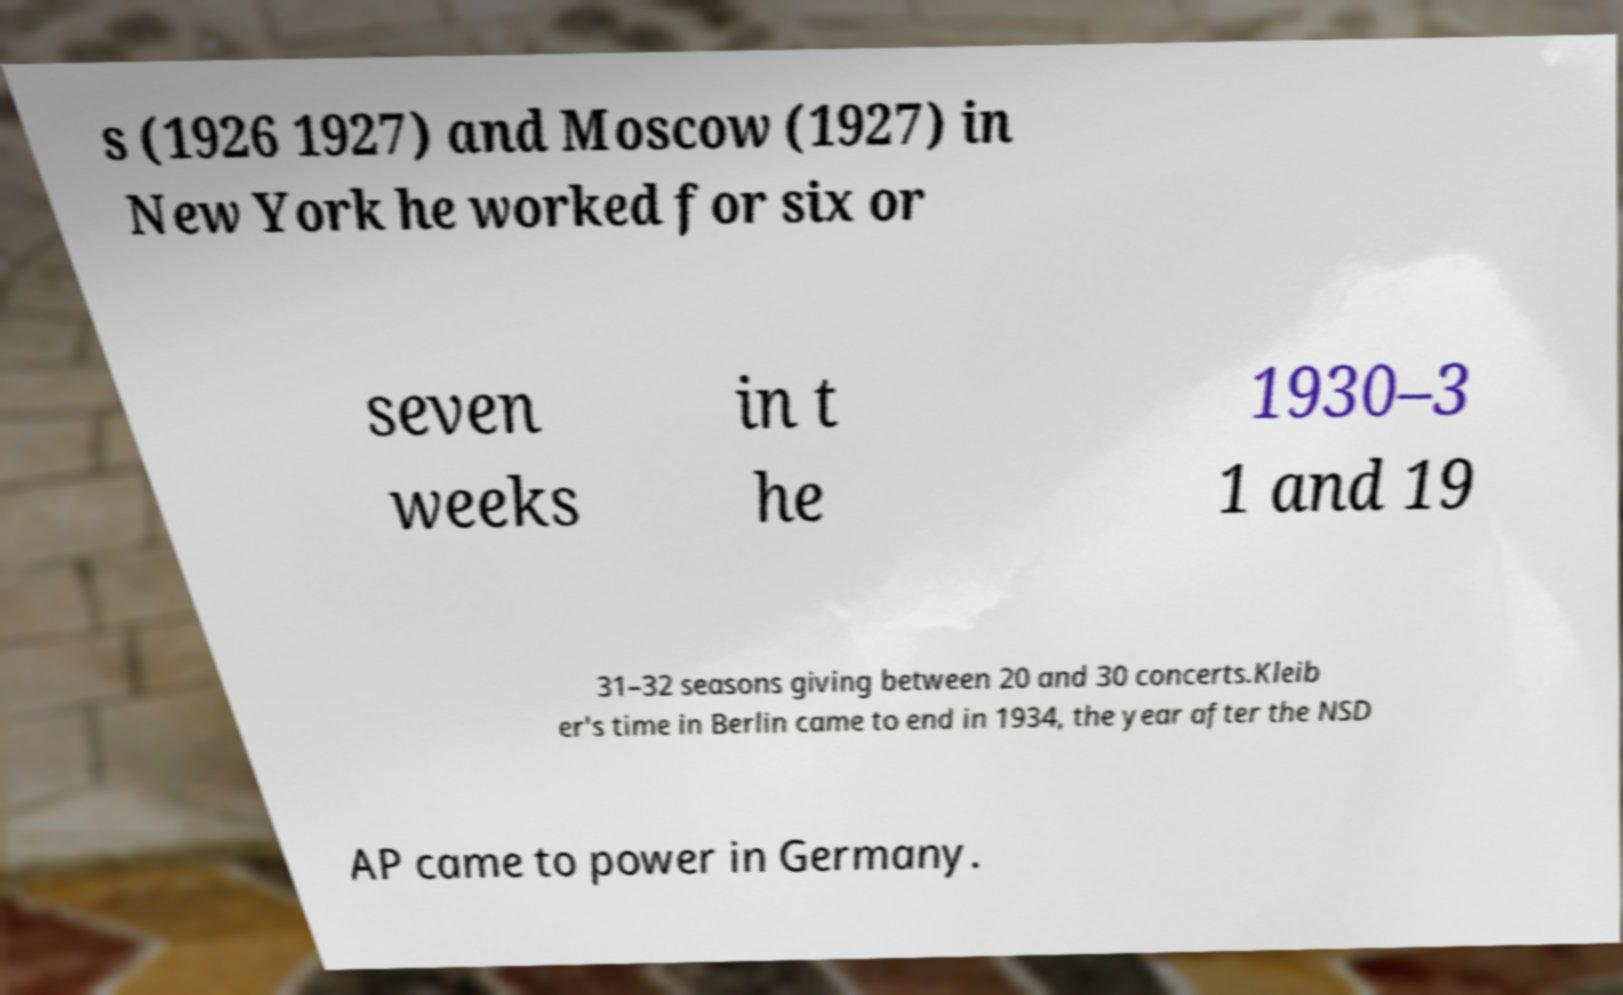For documentation purposes, I need the text within this image transcribed. Could you provide that? s (1926 1927) and Moscow (1927) in New York he worked for six or seven weeks in t he 1930–3 1 and 19 31–32 seasons giving between 20 and 30 concerts.Kleib er's time in Berlin came to end in 1934, the year after the NSD AP came to power in Germany. 